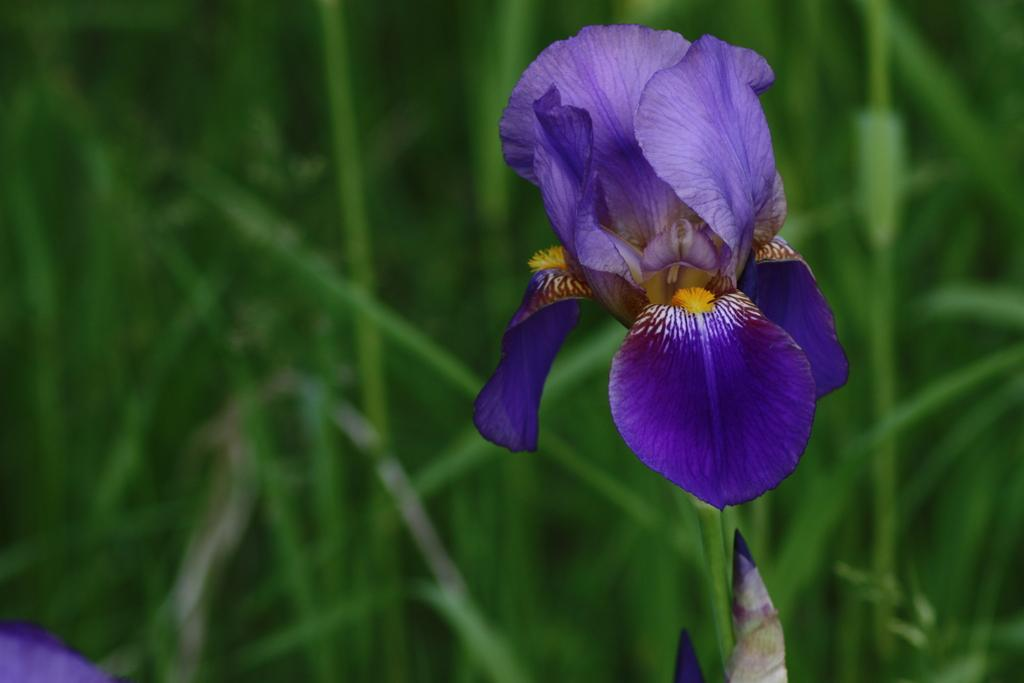What type of plant can be seen in the image? There is a flower in the image. What type of vegetation is present in the image besides the flower? There is grass in the image. Where is the nest located in the image? There is no nest present in the image. What type of condiment is visible in the image? There is no salt or any other condiment visible in the image. 